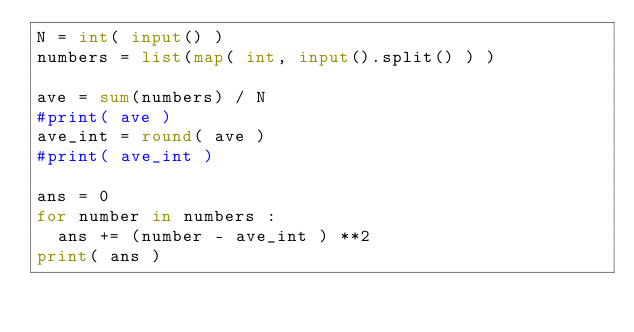<code> <loc_0><loc_0><loc_500><loc_500><_Python_>N = int( input() )
numbers = list(map( int, input().split() ) )

ave = sum(numbers) / N
#print( ave )
ave_int = round( ave )
#print( ave_int )

ans = 0
for number in numbers :
  ans += (number - ave_int ) **2
print( ans )</code> 